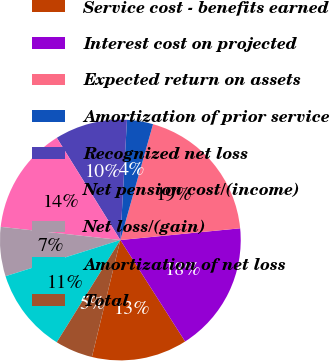<chart> <loc_0><loc_0><loc_500><loc_500><pie_chart><fcel>Service cost - benefits earned<fcel>Interest cost on projected<fcel>Expected return on assets<fcel>Amortization of prior service<fcel>Recognized net loss<fcel>Net pension cost/(income)<fcel>Net loss/(gain)<fcel>Amortization of net loss<fcel>Total<nl><fcel>12.84%<fcel>17.51%<fcel>19.07%<fcel>3.5%<fcel>9.73%<fcel>14.4%<fcel>6.61%<fcel>11.28%<fcel>5.06%<nl></chart> 